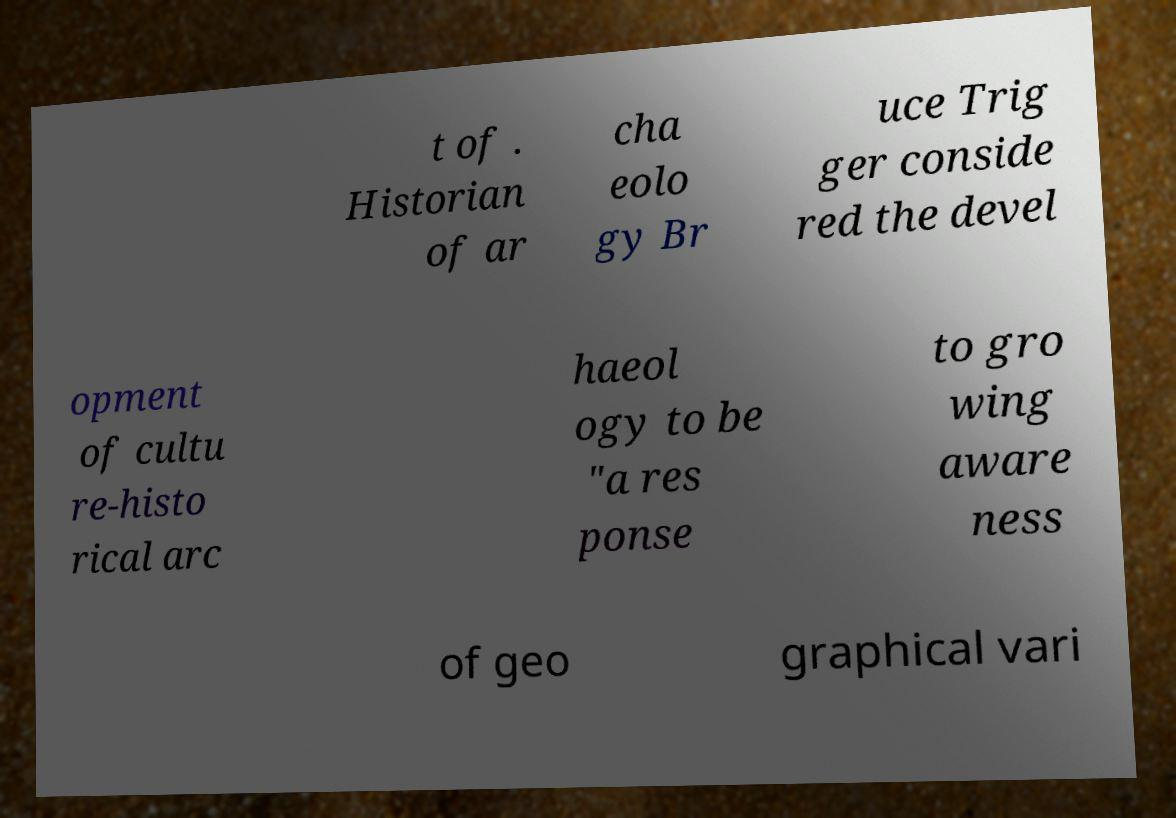Could you extract and type out the text from this image? t of . Historian of ar cha eolo gy Br uce Trig ger conside red the devel opment of cultu re-histo rical arc haeol ogy to be "a res ponse to gro wing aware ness of geo graphical vari 